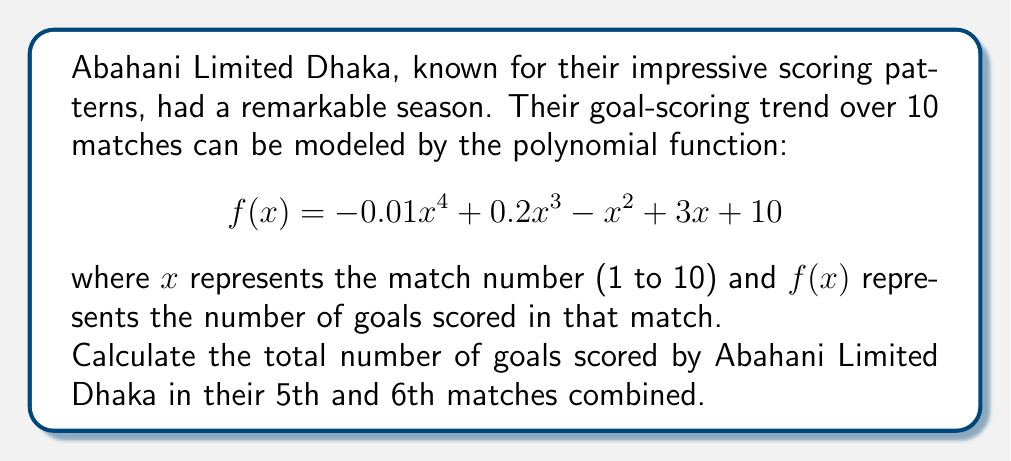Teach me how to tackle this problem. To solve this problem, we need to follow these steps:

1) We have the polynomial function:
   $$f(x) = -0.01x^4 + 0.2x^3 - x^2 + 3x + 10$$

2) We need to find the goals scored in the 5th and 6th matches. So, we'll calculate $f(5)$ and $f(6)$.

3) For the 5th match $(x = 5)$:
   $$\begin{align}
   f(5) &= -0.01(5^4) + 0.2(5^3) - 5^2 + 3(5) + 10 \\
   &= -0.01(625) + 0.2(125) - 25 + 15 + 10 \\
   &= -6.25 + 25 - 25 + 15 + 10 \\
   &= 18.75
   \end{align}$$

4) For the 6th match $(x = 6)$:
   $$\begin{align}
   f(6) &= -0.01(6^4) + 0.2(6^3) - 6^2 + 3(6) + 10 \\
   &= -0.01(1296) + 0.2(216) - 36 + 18 + 10 \\
   &= -12.96 + 43.2 - 36 + 18 + 10 \\
   &= 22.24
   \end{align}$$

5) The total goals scored in the 5th and 6th matches is the sum of these two values:
   $$18.75 + 22.24 = 40.99$$

6) Since we're dealing with goals, which must be whole numbers, we round this to the nearest integer: 41.
Answer: 41 goals 